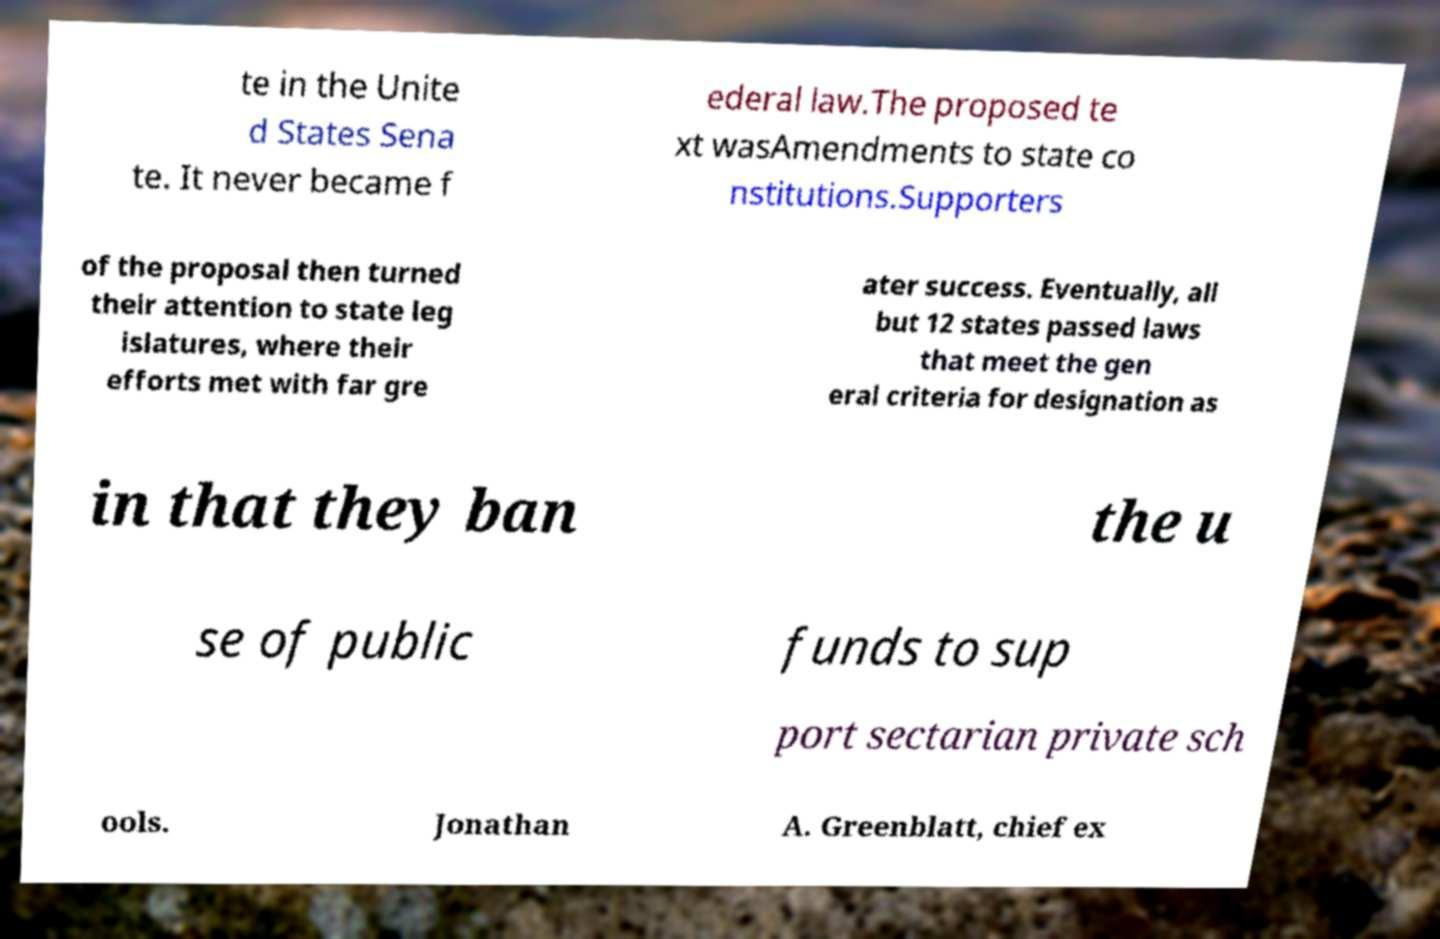Can you accurately transcribe the text from the provided image for me? te in the Unite d States Sena te. It never became f ederal law.The proposed te xt wasAmendments to state co nstitutions.Supporters of the proposal then turned their attention to state leg islatures, where their efforts met with far gre ater success. Eventually, all but 12 states passed laws that meet the gen eral criteria for designation as in that they ban the u se of public funds to sup port sectarian private sch ools. Jonathan A. Greenblatt, chief ex 